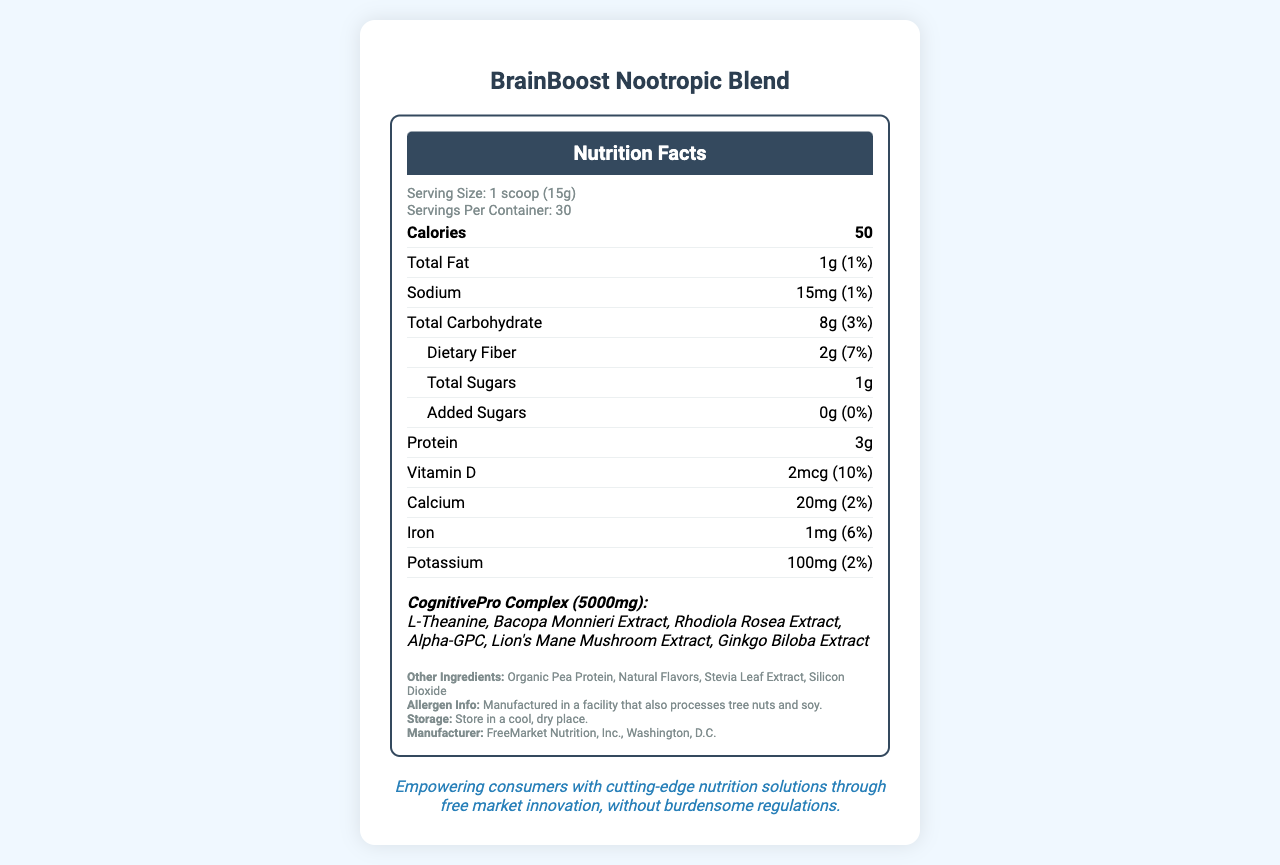what is the serving size of BrainBoost Nootropic Blend? The serving size is stated in the serving information section as "1 scoop (15g)".
Answer: 1 scoop (15g) how many calories does one serving contain? The calories content for one serving is mentioned as "50" under the nutrient section.
Answer: 50 how much dietary fiber is in one serving? The dietary fiber content is given as "2g" for each serving.
Answer: 2g what is the percentage of daily value for Vitamin D? The daily value percentage for Vitamin D is provided as "10%" in the nutrient information.
Answer: 10% how many servings are there per container? The number of servings per container is listed as "30" in the serving information.
Answer: 30 how many grams of protein are in each serving? Each serving contains "3g" of protein as specified in the nutrients section.
Answer: 3g what is the total amount of proprietary blend in one serving? The total amount of the CognitivePro Complex proprietary blend is "5000mg" per serving as mentioned in the document.
Answer: 5000mg which ingredient is not part of the proprietary blend? A. L-Theanine B. Bacopa Monnieri Extract C. Stevia Leaf Extract D. Rhodiola Rosea Extract "Stevia Leaf Extract" is listed under other ingredients, not as part of the proprietary blend.
Answer: C which allergen is the product manufactured with? A. Gluten B. Soy C. Milk D. Eggs The allergen information mentions that it is manufactured in a facility that also processes tree nuts and soy.
Answer: B is the product vegan? The additional information section indicates that the product is vegan.
Answer: Yes is there any added sugar in the product? The label clearly shows "Added Sugars: 0g (0%)", indicating there is no added sugar.
Answer: No describe the document briefly. The document is a comprehensive nutrition facts label for BrainBoost Nootropic Blend. It includes details about serving sizes, nutrients, proprietary blend ingredients, and additional product certifications, along with a statement aligned to a free market approach.
Answer: The document provides the nutrition facts and other related information about the BrainBoost Nootropic Blend. It lists serving size, servings per container, various nutrient contents, and ingredients including a proprietary blend named CognitivePro Complex. It also contains allergen information, storage instructions, manufacturer details, and additional product features like being non-GMO, gluten-free, vegan, and third-party tested. are there any non-GMO ingredients? The document states that the product is non-GMO but does not provide specific details about which ingredients are non-GMO.
Answer: Not enough information does the product contain iron? The product contains "1mg" of Iron which is 6% of the daily value according to the nutrients section.
Answer: Yes what is the manufacturer of BrainBoost Nootropic Blend? The manufacturer information is clearly stated at the bottom of the document as "FreeMarket Nutrition, Inc., Washington, D.C.".
Answer: FreeMarket Nutrition, Inc., Washington, D.C. 